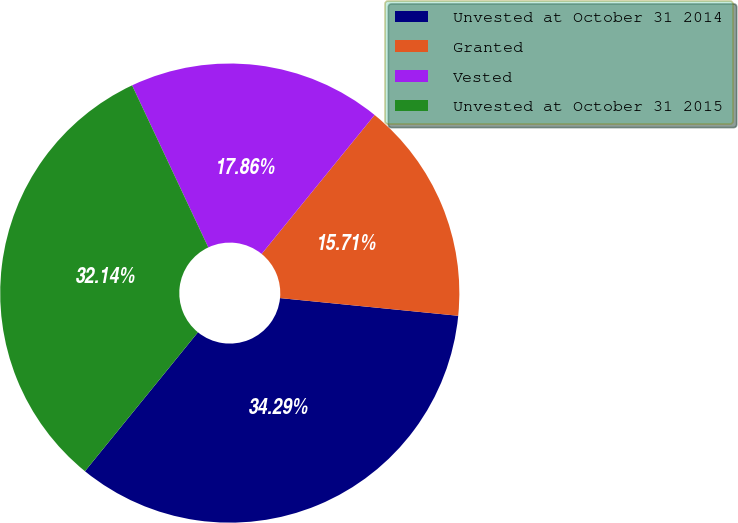<chart> <loc_0><loc_0><loc_500><loc_500><pie_chart><fcel>Unvested at October 31 2014<fcel>Granted<fcel>Vested<fcel>Unvested at October 31 2015<nl><fcel>34.29%<fcel>15.71%<fcel>17.86%<fcel>32.14%<nl></chart> 